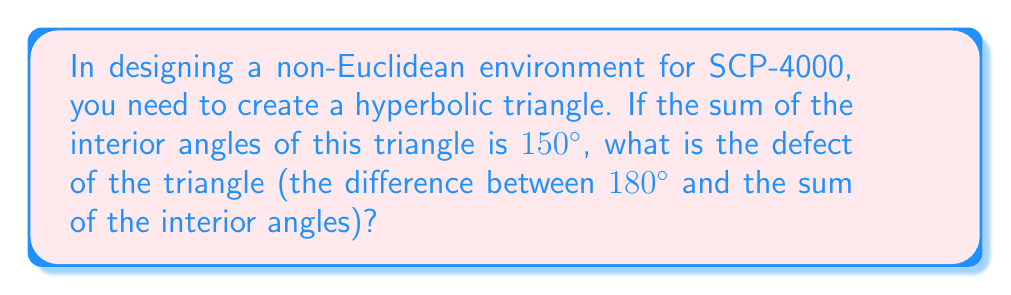Give your solution to this math problem. To solve this problem, we need to follow these steps:

1. Recall that in Euclidean geometry, the sum of interior angles of a triangle is always 180°. However, in hyperbolic geometry, this sum is always less than 180°.

2. The defect of a hyperbolic triangle is defined as the difference between 180° and the sum of its interior angles. Let's call this defect $\delta$.

3. We can express this mathematically as:

   $$\delta = 180° - (\text{sum of interior angles})$$

4. We're given that the sum of the interior angles is 150°. Let's substitute this into our equation:

   $$\delta = 180° - 150°$$

5. Now we can perform the subtraction:

   $$\delta = 30°$$

This result tells us that the triangle's angles deviate from Euclidean geometry by 30°, which could be used to create an unsettling, impossible-seeming environment for the SCP entity.
Answer: 30° 